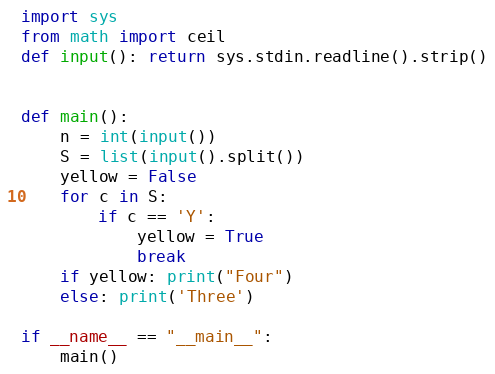<code> <loc_0><loc_0><loc_500><loc_500><_Python_>import sys
from math import ceil
def input(): return sys.stdin.readline().strip()


def main():
    n = int(input())
    S = list(input().split())
    yellow = False
    for c in S:
        if c == 'Y':
            yellow = True
            break
    if yellow: print("Four")
    else: print('Three')

if __name__ == "__main__":
    main()
</code> 